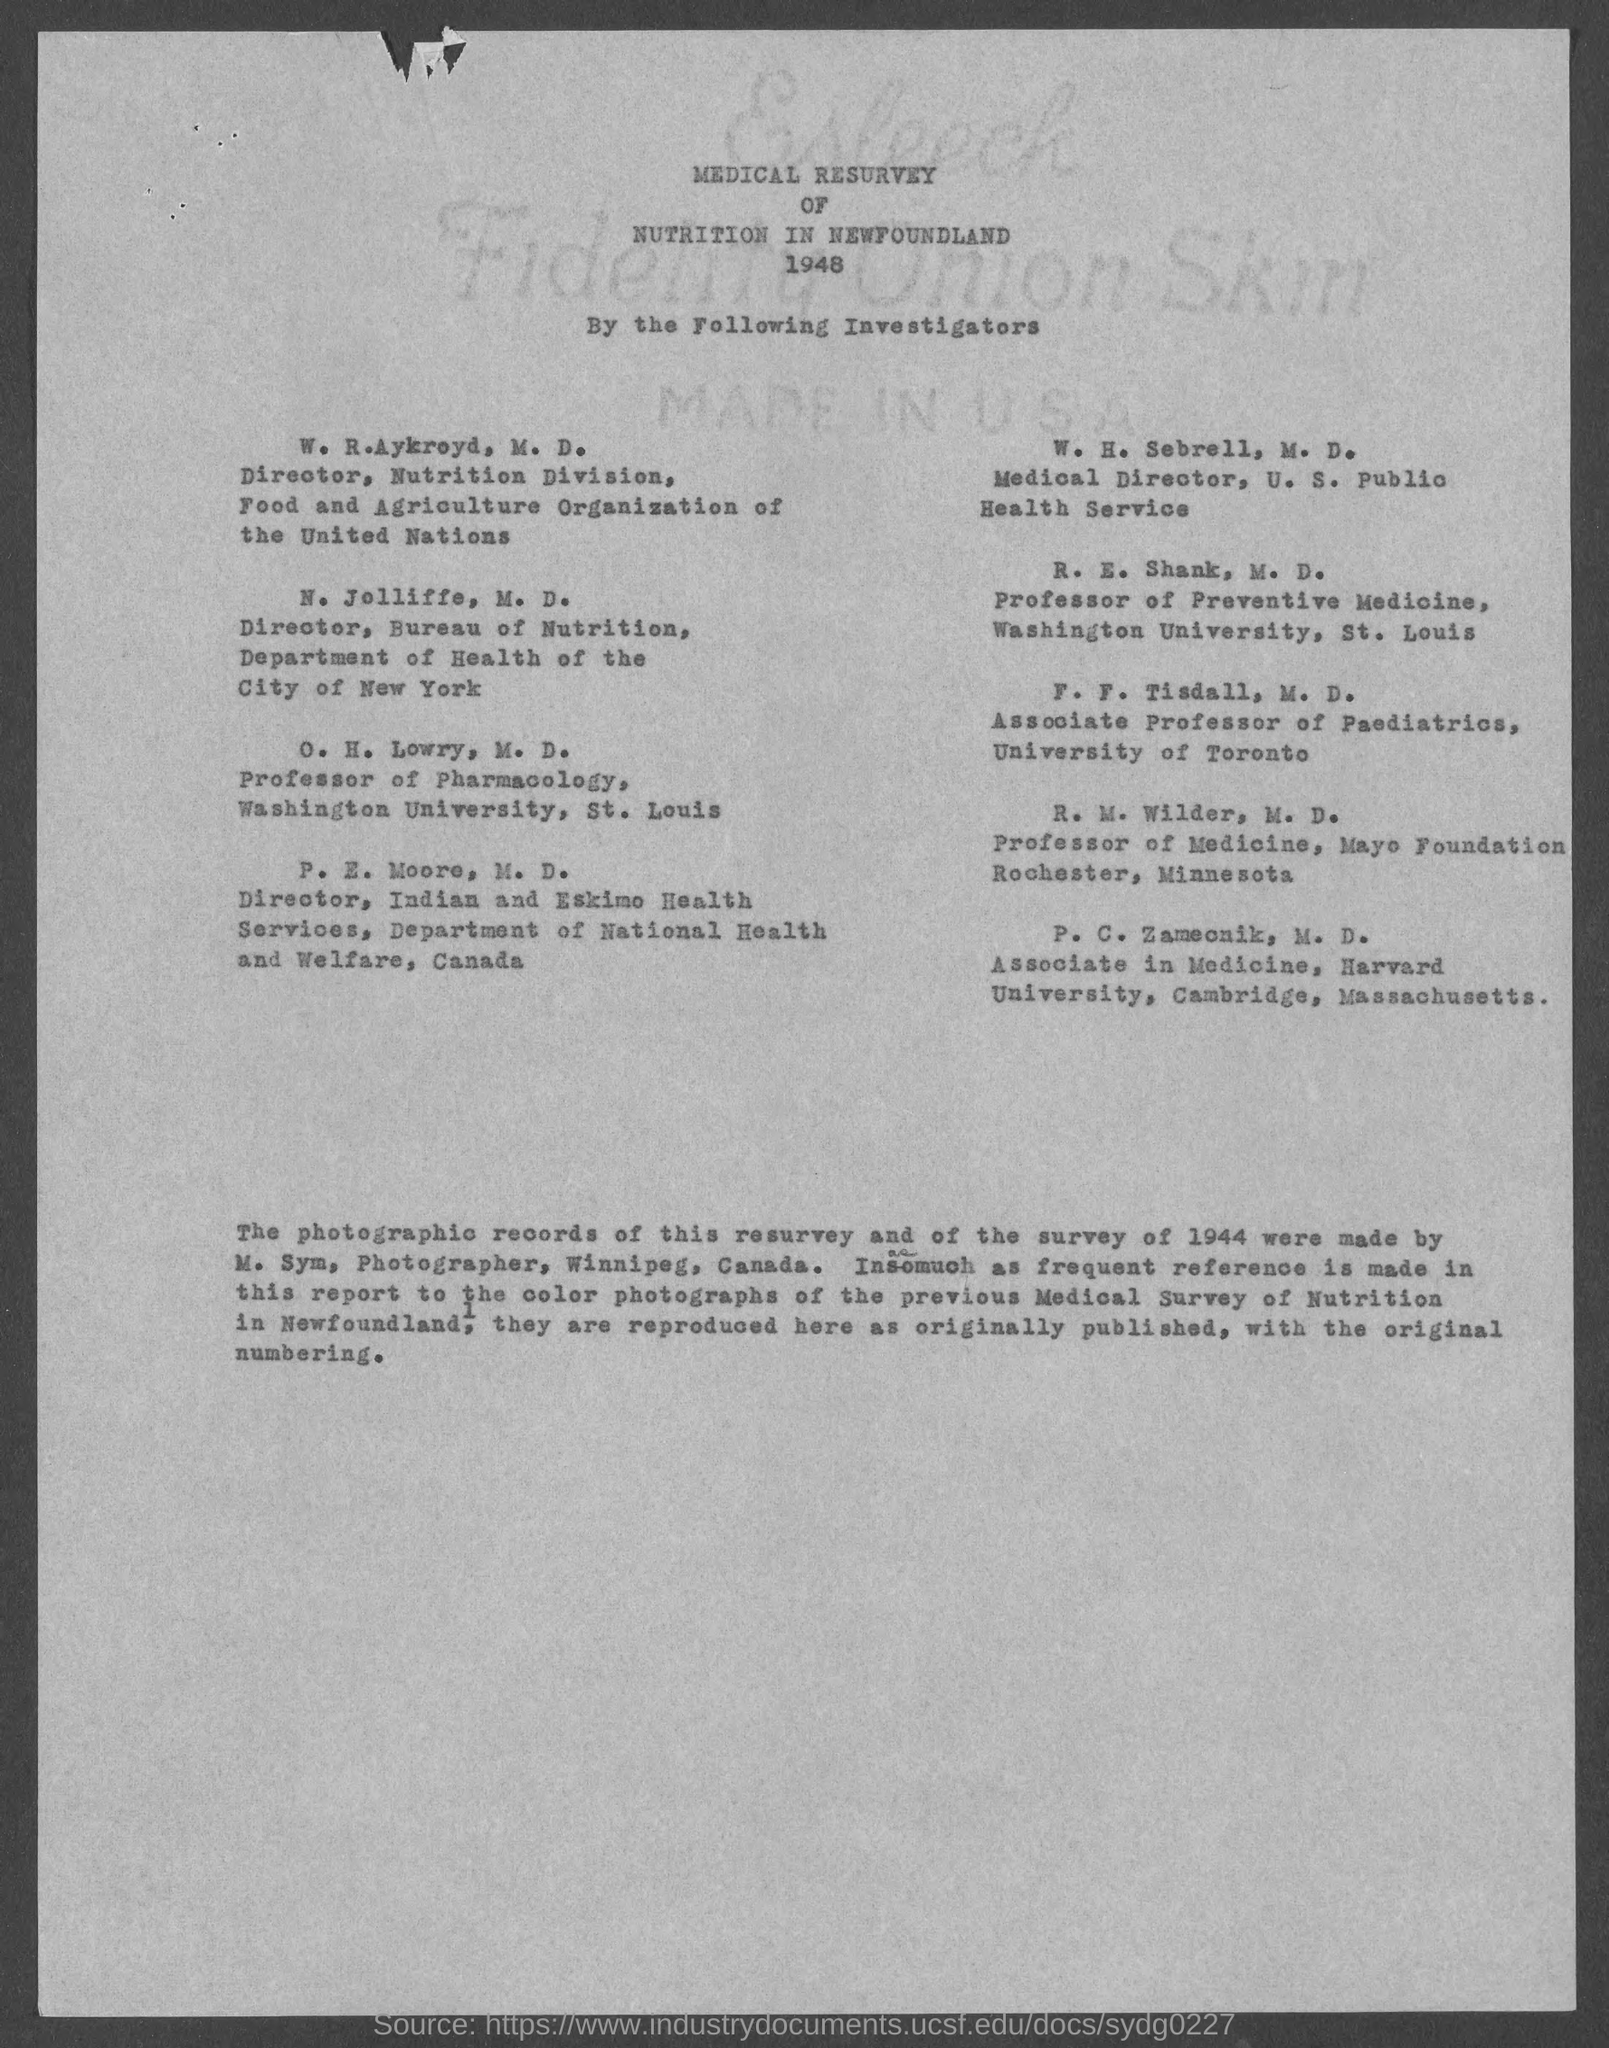Draw attention to some important aspects in this diagram. R. M. Wilder, M.D. holds the position of Professor of Medicine. O. H. Lowry, M.D. holds the position of Professor of Pharmacology. F. F. Tisdall, M.D. holds the position of associate professor of paediatrics. R.E. Shank, M.D. holds the position of Professor of Preventive Medicine. W.H. Sebrell, M.D. holds the position of Medical Director in the medical field. 